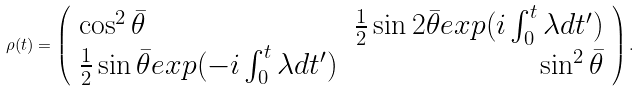<formula> <loc_0><loc_0><loc_500><loc_500>\rho ( t ) = \left ( \begin{array} { l r } \cos ^ { 2 } \bar { \theta } & \frac { 1 } { 2 } \sin 2 \bar { \theta } e x p ( i \int _ { 0 } ^ { t } \lambda d t ^ { \prime } ) \\ \frac { 1 } { 2 } \sin \bar { \theta } e x p ( - i \int _ { 0 } ^ { t } \lambda d t ^ { \prime } ) & \sin ^ { 2 } \bar { \theta } \end{array} \right ) .</formula> 